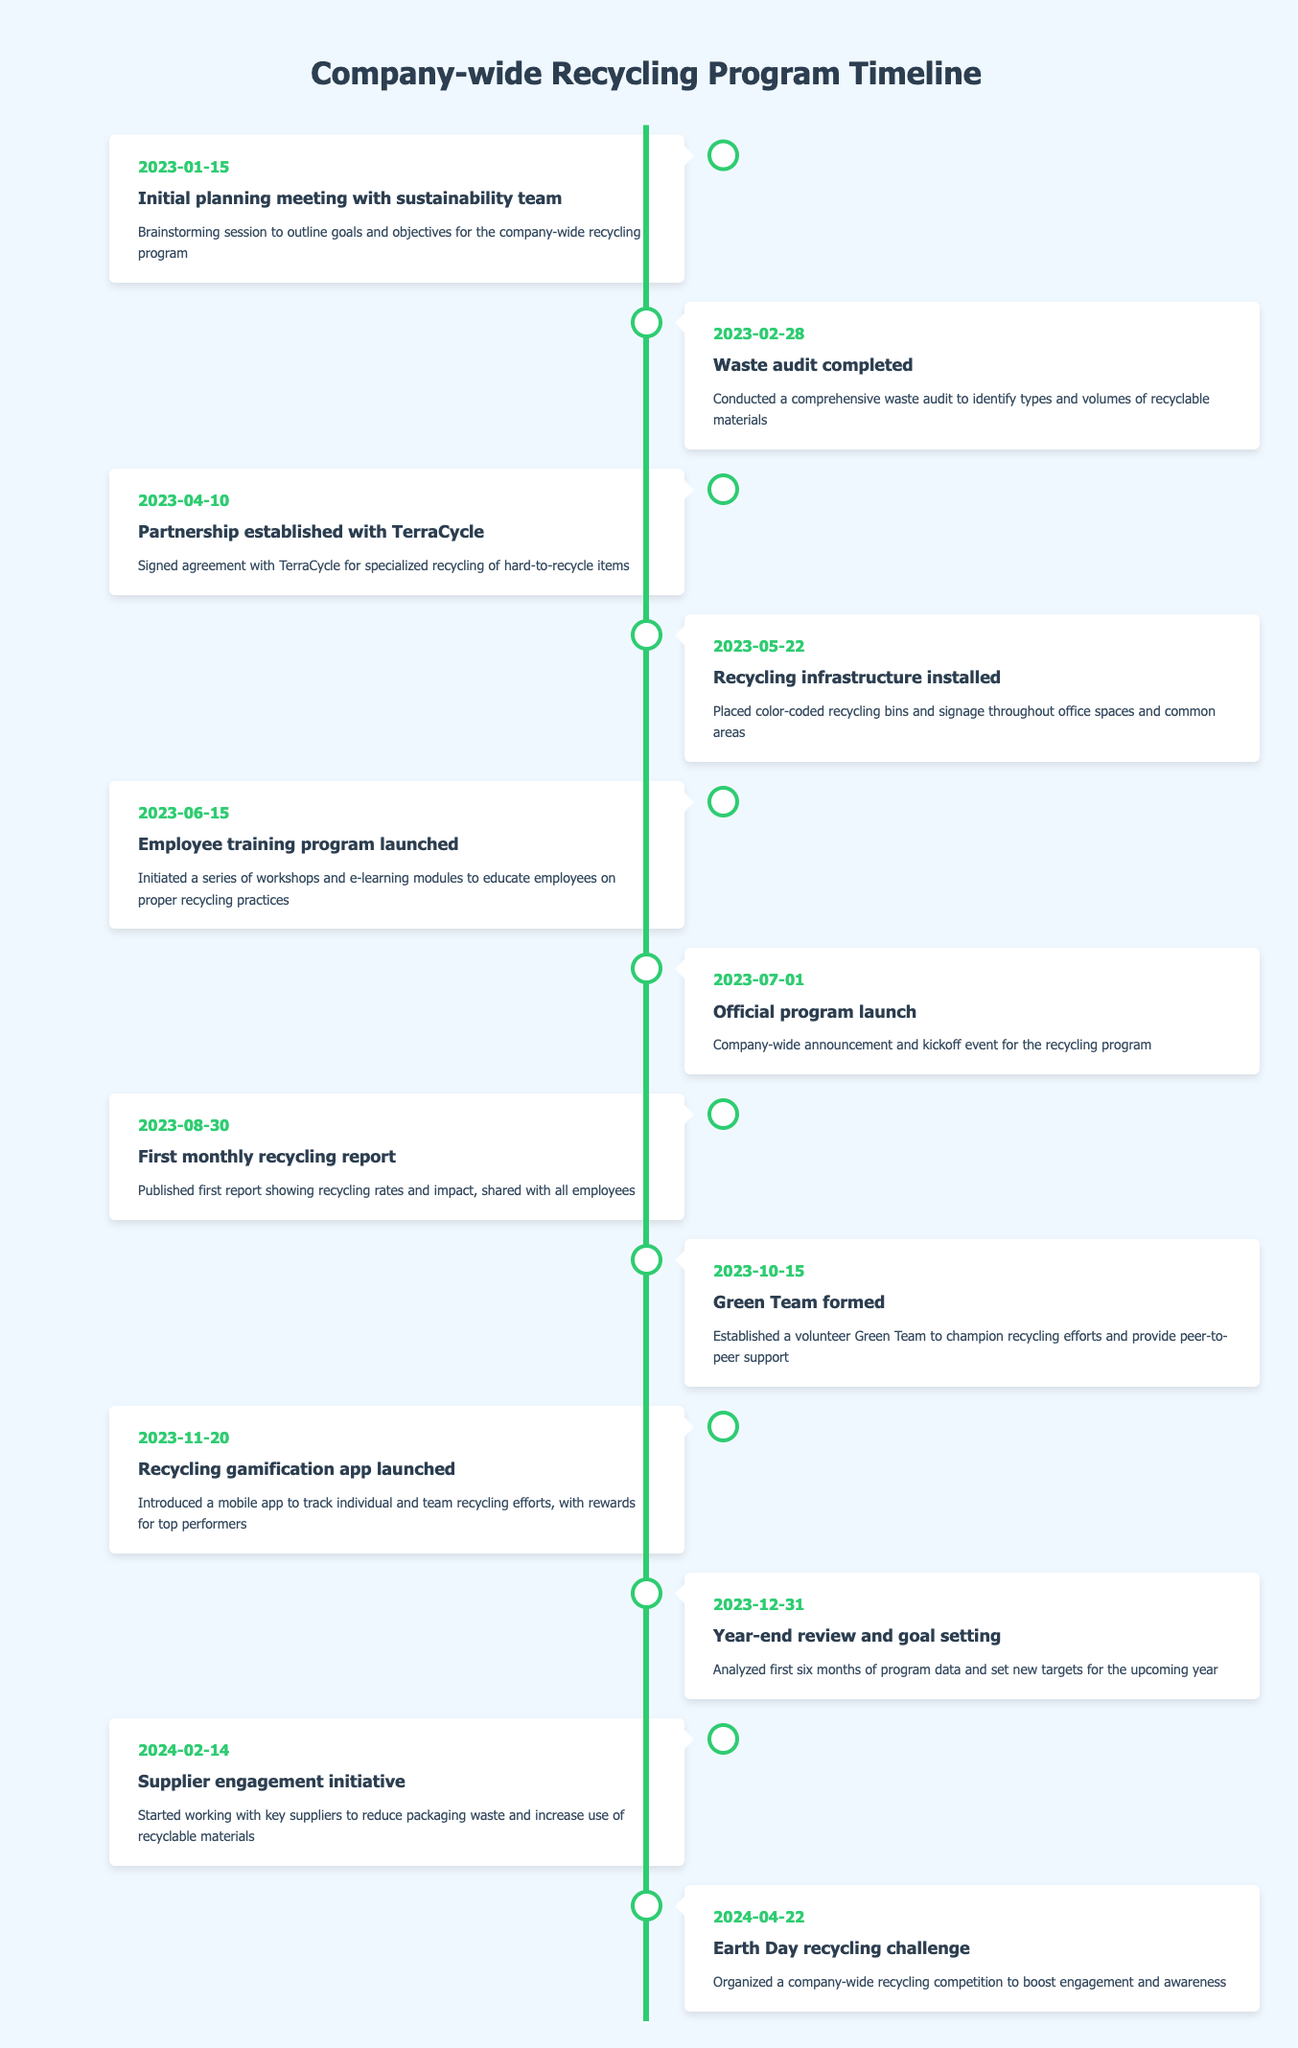What was the date of the official program launch? The official program launch is listed under the milestone on July 1, 2023, where it states "Company-wide announcement and kickoff event for the recycling program." The date can be found directly in the timeline entry.
Answer: July 1, 2023 How many months passed between the waste audit and the employee training program launch? The waste audit was completed on February 28, 2023, and the employee training program was launched on June 15, 2023. Counting the months, it is March, April, May, and part of June, which totals just over three months.
Answer: Approximately 3.5 months Was the Green Team formed before or after the first monthly recycling report? The Green Team was formed on October 15, 2023, and the first monthly recycling report was published on August 30, 2023. Since October comes after August, the Green Team was formed after the first report.
Answer: After How many total milestones were set in the timeline? By counting each provided milestone entry within the timeline, there are 12 distinct milestones listed, starting from the initial planning meeting to the Earth Day recycling challenge.
Answer: 12 What milestone occurred exactly two months after the recycling infrastructure installation? The recycling infrastructure was installed on May 22, 2023. Two months later places it at July 22, 2023, which is just before the official program launch on July 1, 2023. Therefore, prior to the precise two-month mark, the next subsequent milestone is the official program launch on July 1.
Answer: Official program launch How many milestones are there that specifically focus on training or education related to the recycling program? The timeline mentions two specific milestones that focus on training and education: one on June 15, 2023, for the employee training program launch and another on November 20, 2023, for the recycling gamification app launch, which also aims to educate employees. Thus, the total is 2.
Answer: 2 What is the earliest milestone in the timeline? The earliest milestone is clearly identified as the "Initial planning meeting with sustainability team" on January 15, 2023. This entry is the first in the sequence of events listed in the timeline.
Answer: January 15, 2023 How long was the period from the initial planning meeting to the year-end review and goal setting? The initial planning meeting occurred on January 15, 2023, and the year-end review and goal setting took place on December 31, 2023. Calculating from mid-January to the end of December gives us a total of almost 12 months.
Answer: Almost 12 months Which milestone was focused on engaging suppliers, and when did it occur? The milestone related to engaging suppliers is labeled "Supplier engagement initiative," and it took place on February 14, 2024, as indicated in the timeline. This information can be retrieved from the specific entry about supplier engagement.
Answer: February 14, 2024 